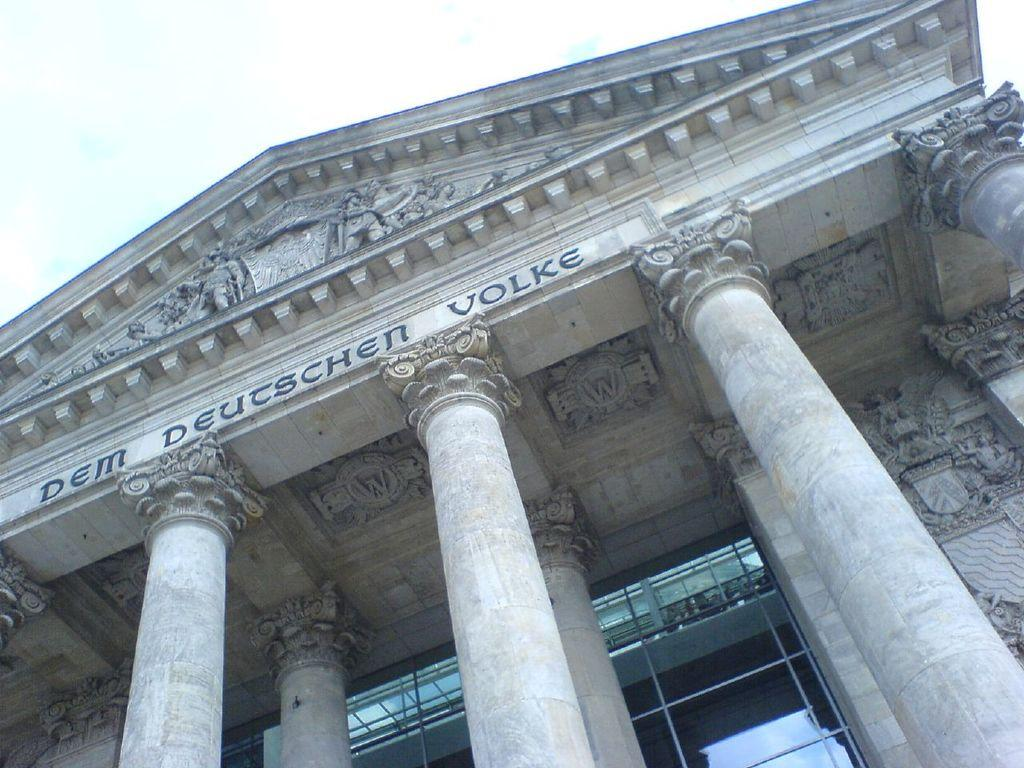What type of structure is visible in the image? There is a building in the image. What architectural features can be seen on the building? The building has pillars and glass doors. Are there any decorative elements on the building? Yes, there are sculptures on the building. What type of inscriptions are present on the building? Letters are carved on the building. What type of boot is hanging from the sculpture on the building? There is no boot present in the image; it features a building with pillars, glass doors, sculptures, and carved letters. 